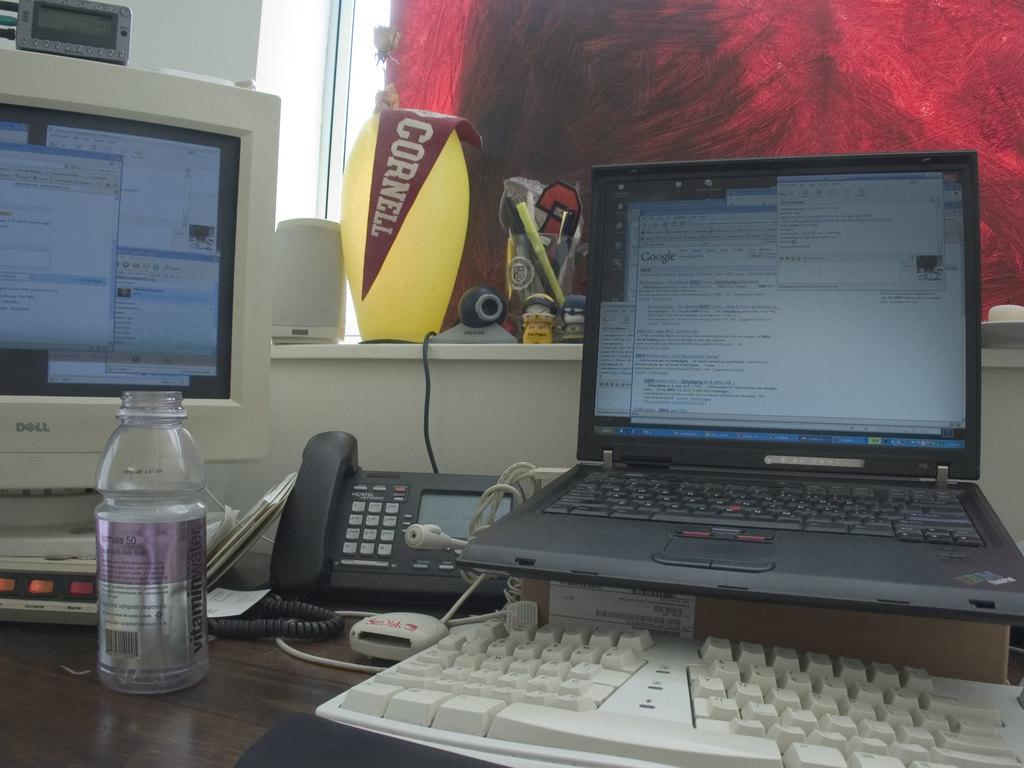Provide a one-sentence caption for the provided image. A white, Dell desktop computer sitting to the left of an opened black laptop on a desk. 